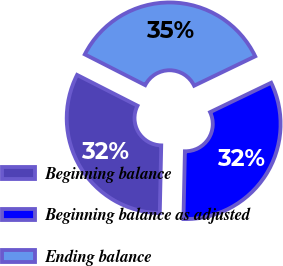<chart> <loc_0><loc_0><loc_500><loc_500><pie_chart><fcel>Beginning balance<fcel>Beginning balance as adjusted<fcel>Ending balance<nl><fcel>32.16%<fcel>32.48%<fcel>35.36%<nl></chart> 